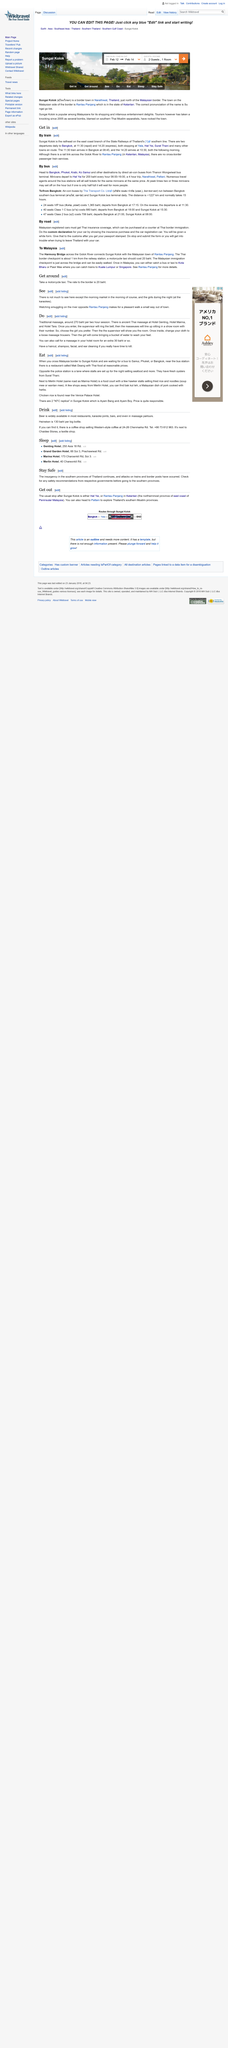Indicate a few pertinent items in this graphic. Beer is readily available in restaurants, karaoke joints, bars, and even in massage parlours. It is possible to observe smuggling activities from the river opposite Rantau Panjang. The cost of a traditional Thai massage per hour is approximately 270 baht. At the Hotel Genting, Hotel Marina, and Hotel Tara, ancient Thai massage can be found. Yes, it is possible to get a haircut and massage in a hotel room. 